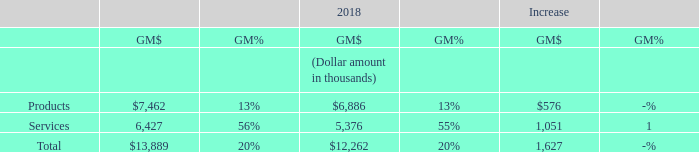The impact of product mix within our TS segment on gross margins for the fiscal years ended September 30 was as follows:
The overall TS segment gross margin as a percentage of sales remained the same in fiscal year 2019 when compared to fiscal year 2018. The $0.6 million increase in our TS segment product gross margins resulted from an increase in product revenues in the U.S. division, partially offset by a decrease in the U.K division. The $1.1 million.increase in the TS segment service gross margins primarily resulted from increased service revenues in the U.S. division.
When is the company's financial year end? September 30. How many product mixes does the company have? 2. What is the company's total gross margin in 2019?
Answer scale should be: thousand. $13,889. What is the company's total revenue in 2019?
Answer scale should be: thousand. $13,889/20% 
Answer: 69445. What percentage of the company's total gross margin arises from products?
Answer scale should be: percent. $7,462/$13,889 
Answer: 53.73. What is the percentage change in gross margins from services between 2018 and 2019?
Answer scale should be: percent. (6,427 - 5,376)/5,376 
Answer: 19.55. 